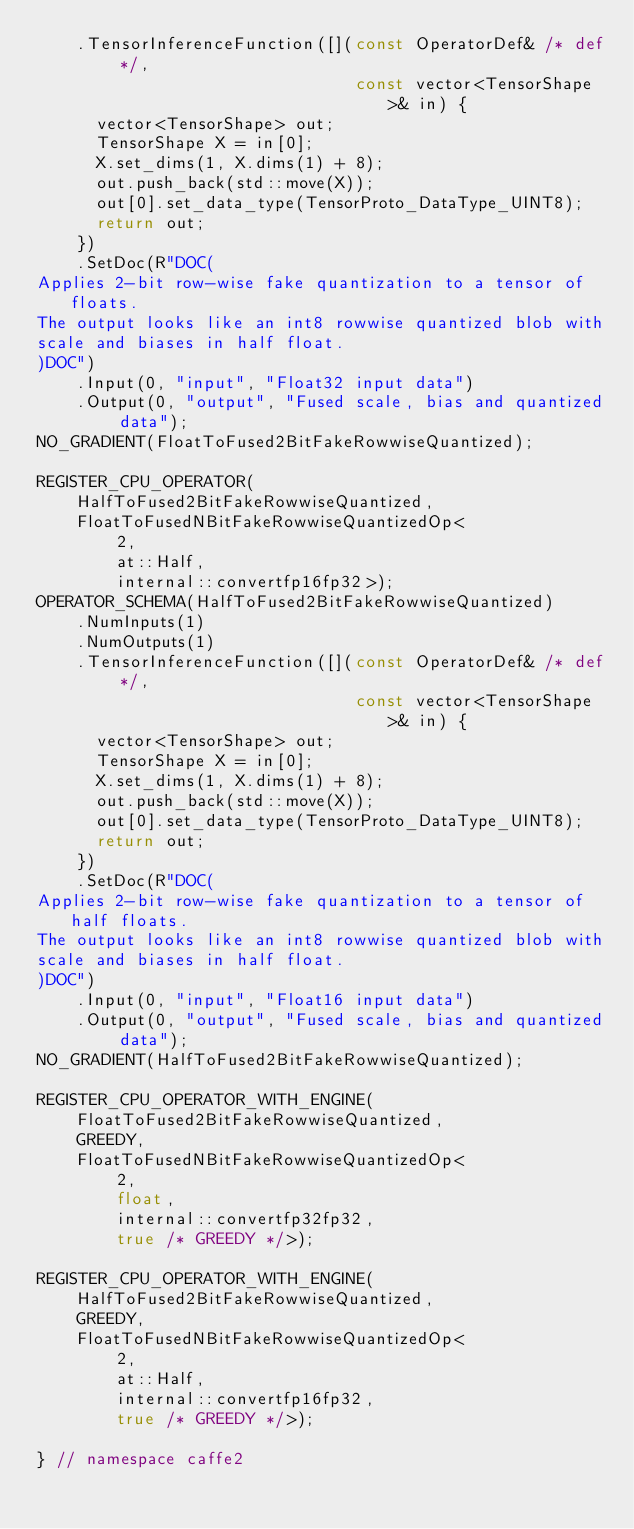<code> <loc_0><loc_0><loc_500><loc_500><_C++_>    .TensorInferenceFunction([](const OperatorDef& /* def */,
                                const vector<TensorShape>& in) {
      vector<TensorShape> out;
      TensorShape X = in[0];
      X.set_dims(1, X.dims(1) + 8);
      out.push_back(std::move(X));
      out[0].set_data_type(TensorProto_DataType_UINT8);
      return out;
    })
    .SetDoc(R"DOC(
Applies 2-bit row-wise fake quantization to a tensor of floats.
The output looks like an int8 rowwise quantized blob with
scale and biases in half float.
)DOC")
    .Input(0, "input", "Float32 input data")
    .Output(0, "output", "Fused scale, bias and quantized data");
NO_GRADIENT(FloatToFused2BitFakeRowwiseQuantized);

REGISTER_CPU_OPERATOR(
    HalfToFused2BitFakeRowwiseQuantized,
    FloatToFusedNBitFakeRowwiseQuantizedOp<
        2,
        at::Half,
        internal::convertfp16fp32>);
OPERATOR_SCHEMA(HalfToFused2BitFakeRowwiseQuantized)
    .NumInputs(1)
    .NumOutputs(1)
    .TensorInferenceFunction([](const OperatorDef& /* def */,
                                const vector<TensorShape>& in) {
      vector<TensorShape> out;
      TensorShape X = in[0];
      X.set_dims(1, X.dims(1) + 8);
      out.push_back(std::move(X));
      out[0].set_data_type(TensorProto_DataType_UINT8);
      return out;
    })
    .SetDoc(R"DOC(
Applies 2-bit row-wise fake quantization to a tensor of half floats.
The output looks like an int8 rowwise quantized blob with
scale and biases in half float.
)DOC")
    .Input(0, "input", "Float16 input data")
    .Output(0, "output", "Fused scale, bias and quantized data");
NO_GRADIENT(HalfToFused2BitFakeRowwiseQuantized);

REGISTER_CPU_OPERATOR_WITH_ENGINE(
    FloatToFused2BitFakeRowwiseQuantized,
    GREEDY,
    FloatToFusedNBitFakeRowwiseQuantizedOp<
        2,
        float,
        internal::convertfp32fp32,
        true /* GREEDY */>);

REGISTER_CPU_OPERATOR_WITH_ENGINE(
    HalfToFused2BitFakeRowwiseQuantized,
    GREEDY,
    FloatToFusedNBitFakeRowwiseQuantizedOp<
        2,
        at::Half,
        internal::convertfp16fp32,
        true /* GREEDY */>);

} // namespace caffe2
</code> 